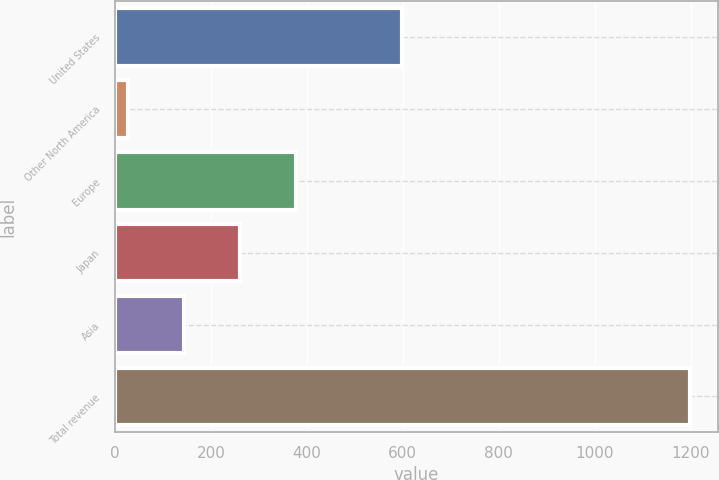Convert chart. <chart><loc_0><loc_0><loc_500><loc_500><bar_chart><fcel>United States<fcel>Other North America<fcel>Europe<fcel>Japan<fcel>Asia<fcel>Total revenue<nl><fcel>598.9<fcel>27<fcel>378.15<fcel>261.1<fcel>144.05<fcel>1197.5<nl></chart> 